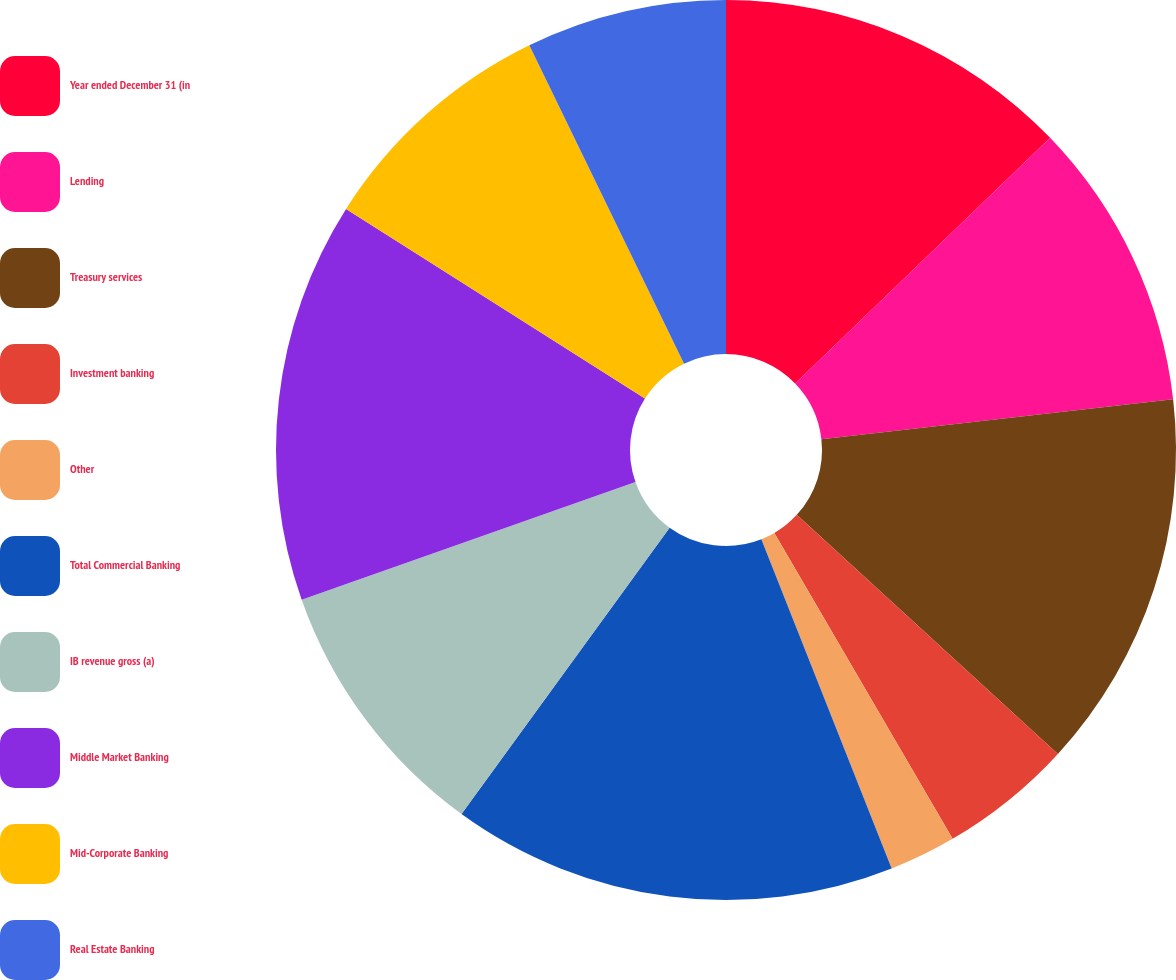Convert chart. <chart><loc_0><loc_0><loc_500><loc_500><pie_chart><fcel>Year ended December 31 (in<fcel>Lending<fcel>Treasury services<fcel>Investment banking<fcel>Other<fcel>Total Commercial Banking<fcel>IB revenue gross (a)<fcel>Middle Market Banking<fcel>Mid-Corporate Banking<fcel>Real Estate Banking<nl><fcel>12.8%<fcel>10.4%<fcel>13.6%<fcel>4.8%<fcel>2.4%<fcel>16.0%<fcel>9.6%<fcel>14.4%<fcel>8.8%<fcel>7.2%<nl></chart> 